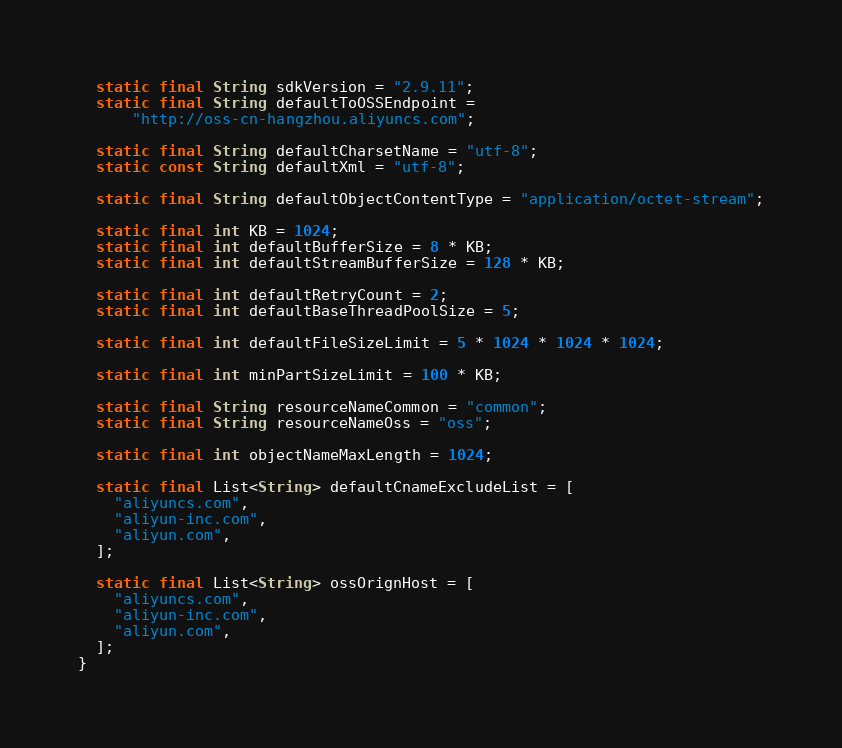<code> <loc_0><loc_0><loc_500><loc_500><_Dart_>  static final String sdkVersion = "2.9.11";
  static final String defaultToOSSEndpoint =
      "http://oss-cn-hangzhou.aliyuncs.com";

  static final String defaultCharsetName = "utf-8";
  static const String defaultXml = "utf-8";

  static final String defaultObjectContentType = "application/octet-stream";

  static final int KB = 1024;
  static final int defaultBufferSize = 8 * KB;
  static final int defaultStreamBufferSize = 128 * KB;

  static final int defaultRetryCount = 2;
  static final int defaultBaseThreadPoolSize = 5;

  static final int defaultFileSizeLimit = 5 * 1024 * 1024 * 1024;

  static final int minPartSizeLimit = 100 * KB;

  static final String resourceNameCommon = "common";
  static final String resourceNameOss = "oss";

  static final int objectNameMaxLength = 1024;

  static final List<String> defaultCnameExcludeList = [
    "aliyuncs.com",
    "aliyun-inc.com",
    "aliyun.com",
  ];

  static final List<String> ossOrignHost = [
    "aliyuncs.com",
    "aliyun-inc.com",
    "aliyun.com",
  ];
}
</code> 